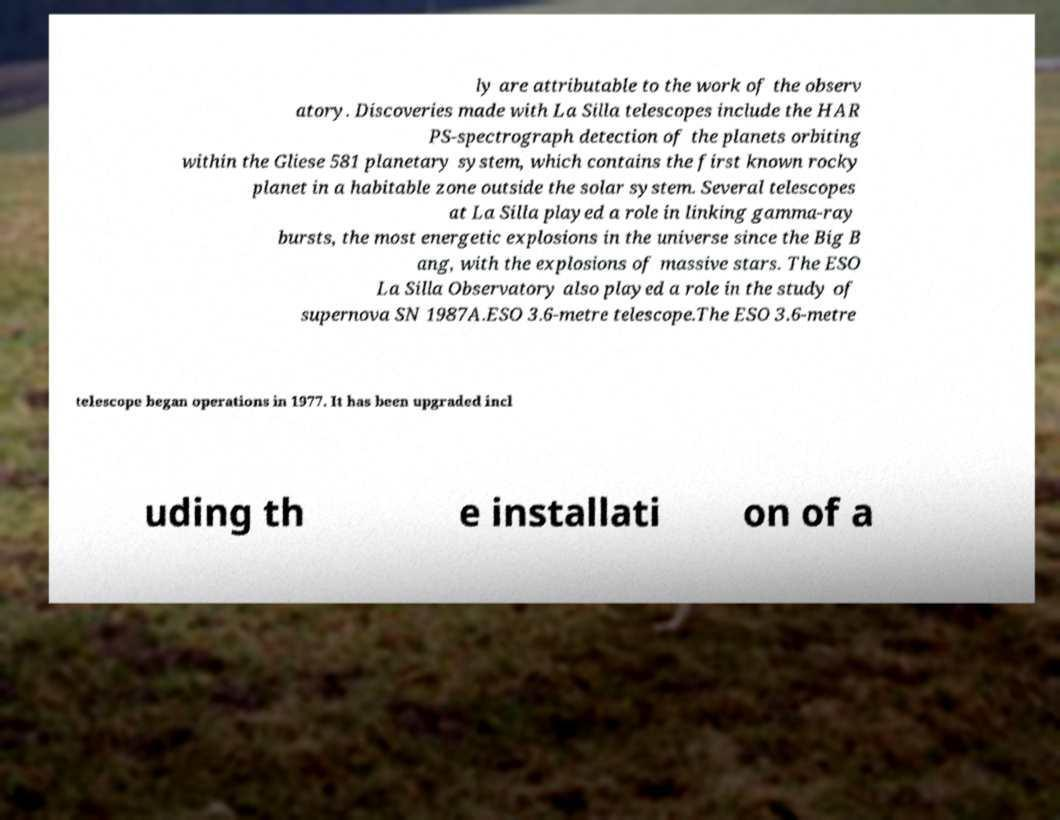Please read and relay the text visible in this image. What does it say? ly are attributable to the work of the observ atory. Discoveries made with La Silla telescopes include the HAR PS-spectrograph detection of the planets orbiting within the Gliese 581 planetary system, which contains the first known rocky planet in a habitable zone outside the solar system. Several telescopes at La Silla played a role in linking gamma-ray bursts, the most energetic explosions in the universe since the Big B ang, with the explosions of massive stars. The ESO La Silla Observatory also played a role in the study of supernova SN 1987A.ESO 3.6-metre telescope.The ESO 3.6-metre telescope began operations in 1977. It has been upgraded incl uding th e installati on of a 